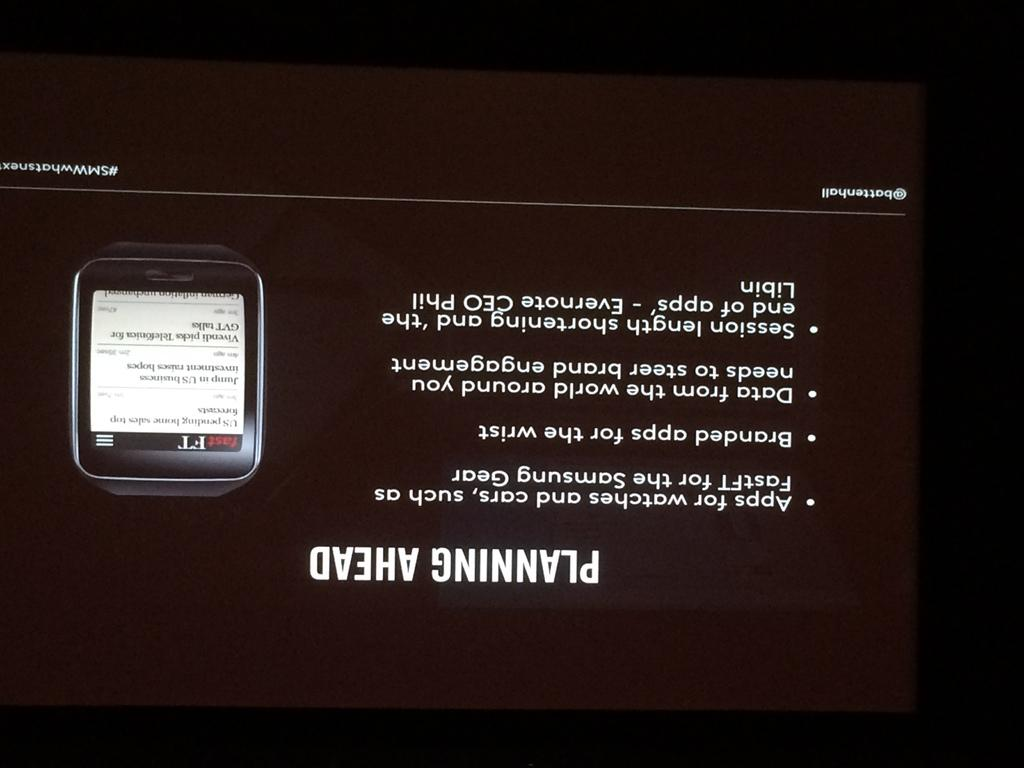<image>
Summarize the visual content of the image. A screen with the title Planning Ahead upside down. 